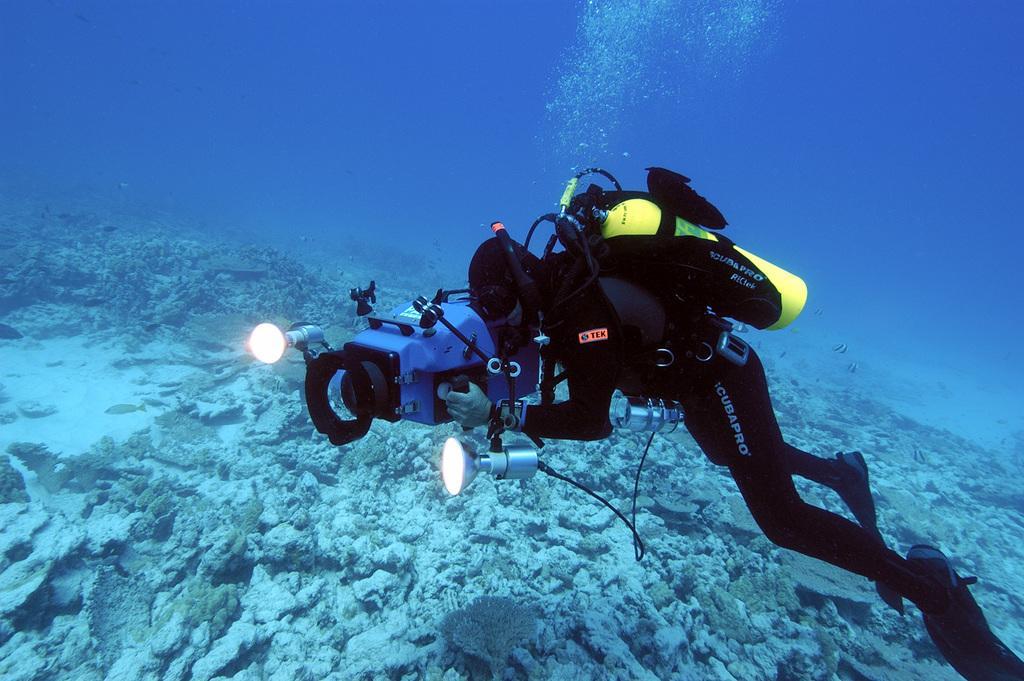Describe this image in one or two sentences. In this image there is a man in the water. The man is wearing the black colour dress and holding the light. He also has an oxygen cylinder on his back. At the bottom there are so many stones and aquatic plants. 